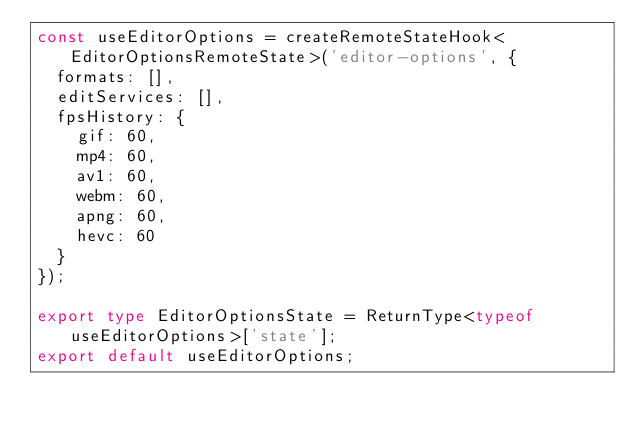<code> <loc_0><loc_0><loc_500><loc_500><_TypeScript_>const useEditorOptions = createRemoteStateHook<EditorOptionsRemoteState>('editor-options', {
  formats: [],
  editServices: [],
  fpsHistory: {
    gif: 60,
    mp4: 60,
    av1: 60,
    webm: 60,
    apng: 60,
    hevc: 60
  }
});

export type EditorOptionsState = ReturnType<typeof useEditorOptions>['state'];
export default useEditorOptions;
</code> 